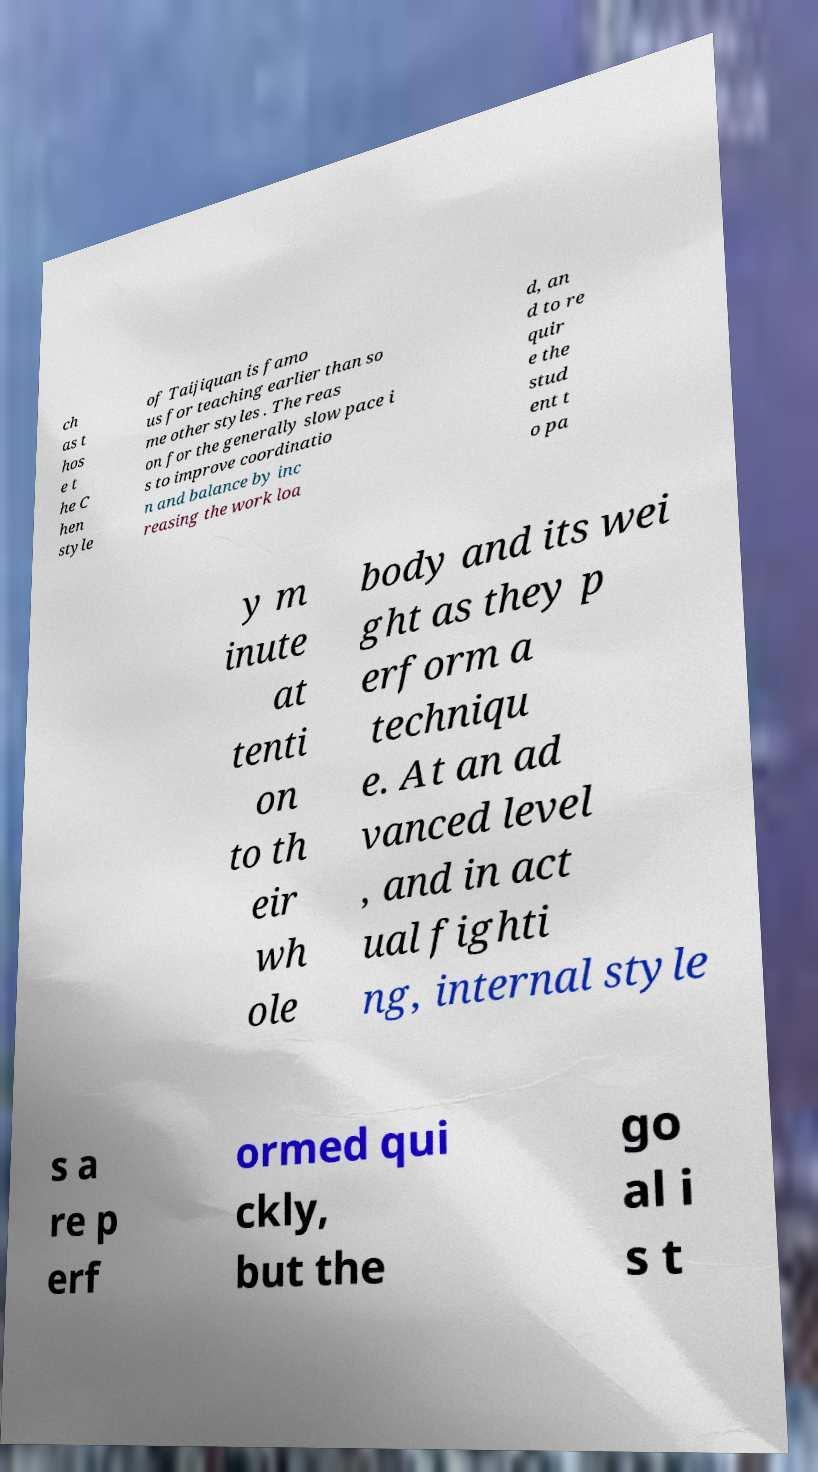For documentation purposes, I need the text within this image transcribed. Could you provide that? ch as t hos e t he C hen style of Taijiquan is famo us for teaching earlier than so me other styles . The reas on for the generally slow pace i s to improve coordinatio n and balance by inc reasing the work loa d, an d to re quir e the stud ent t o pa y m inute at tenti on to th eir wh ole body and its wei ght as they p erform a techniqu e. At an ad vanced level , and in act ual fighti ng, internal style s a re p erf ormed qui ckly, but the go al i s t 